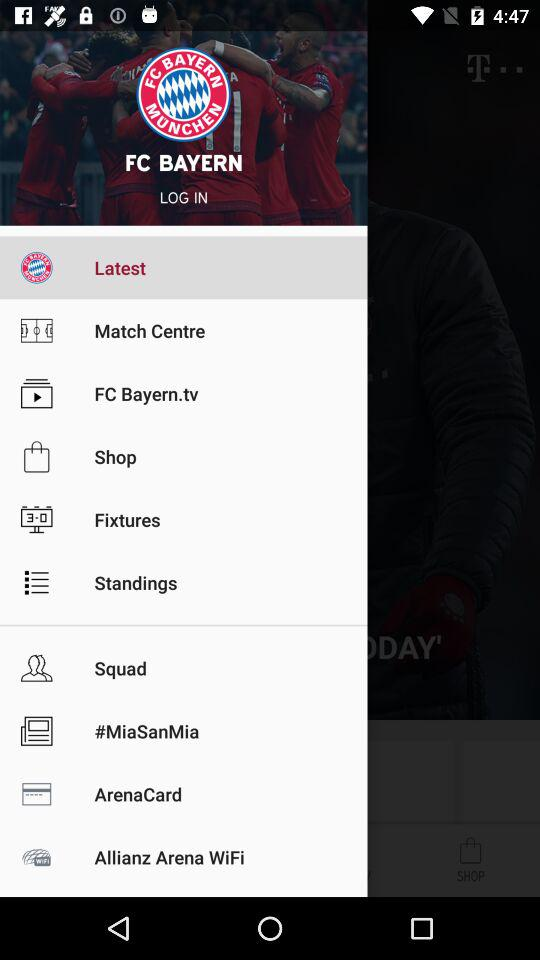What is the name of the application? The name of the application is "FC BAYERN". 